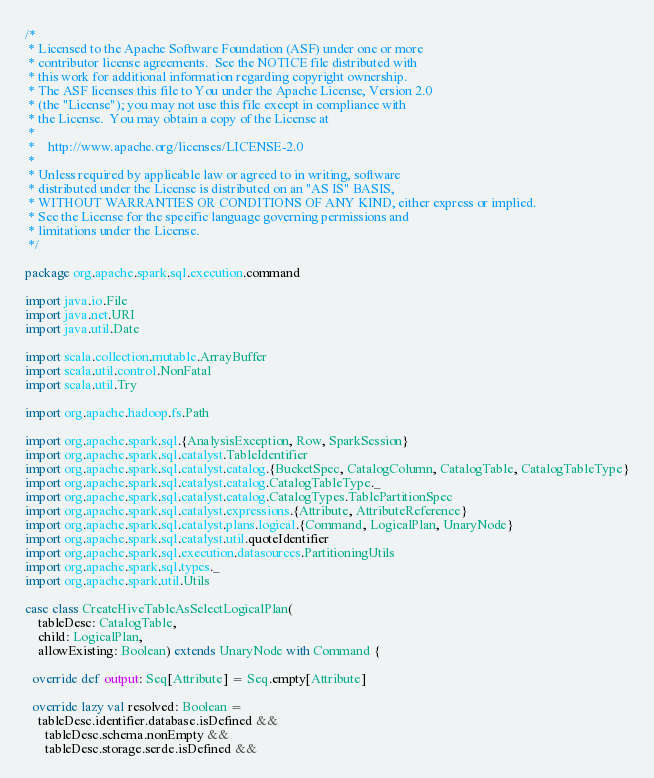Convert code to text. <code><loc_0><loc_0><loc_500><loc_500><_Scala_>/*
 * Licensed to the Apache Software Foundation (ASF) under one or more
 * contributor license agreements.  See the NOTICE file distributed with
 * this work for additional information regarding copyright ownership.
 * The ASF licenses this file to You under the Apache License, Version 2.0
 * (the "License"); you may not use this file except in compliance with
 * the License.  You may obtain a copy of the License at
 *
 *    http://www.apache.org/licenses/LICENSE-2.0
 *
 * Unless required by applicable law or agreed to in writing, software
 * distributed under the License is distributed on an "AS IS" BASIS,
 * WITHOUT WARRANTIES OR CONDITIONS OF ANY KIND, either express or implied.
 * See the License for the specific language governing permissions and
 * limitations under the License.
 */

package org.apache.spark.sql.execution.command

import java.io.File
import java.net.URI
import java.util.Date

import scala.collection.mutable.ArrayBuffer
import scala.util.control.NonFatal
import scala.util.Try

import org.apache.hadoop.fs.Path

import org.apache.spark.sql.{AnalysisException, Row, SparkSession}
import org.apache.spark.sql.catalyst.TableIdentifier
import org.apache.spark.sql.catalyst.catalog.{BucketSpec, CatalogColumn, CatalogTable, CatalogTableType}
import org.apache.spark.sql.catalyst.catalog.CatalogTableType._
import org.apache.spark.sql.catalyst.catalog.CatalogTypes.TablePartitionSpec
import org.apache.spark.sql.catalyst.expressions.{Attribute, AttributeReference}
import org.apache.spark.sql.catalyst.plans.logical.{Command, LogicalPlan, UnaryNode}
import org.apache.spark.sql.catalyst.util.quoteIdentifier
import org.apache.spark.sql.execution.datasources.PartitioningUtils
import org.apache.spark.sql.types._
import org.apache.spark.util.Utils

case class CreateHiveTableAsSelectLogicalPlan(
    tableDesc: CatalogTable,
    child: LogicalPlan,
    allowExisting: Boolean) extends UnaryNode with Command {

  override def output: Seq[Attribute] = Seq.empty[Attribute]

  override lazy val resolved: Boolean =
    tableDesc.identifier.database.isDefined &&
      tableDesc.schema.nonEmpty &&
      tableDesc.storage.serde.isDefined &&</code> 